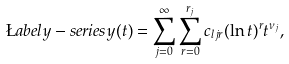<formula> <loc_0><loc_0><loc_500><loc_500>\L a b e l { y - s e r i e s } y ( t ) = \sum _ { j = 0 } ^ { \infty } \sum _ { r = 0 } ^ { r _ { j } } c _ { l j r } ( \ln t ) ^ { r } t ^ { \nu _ { j } } ,</formula> 